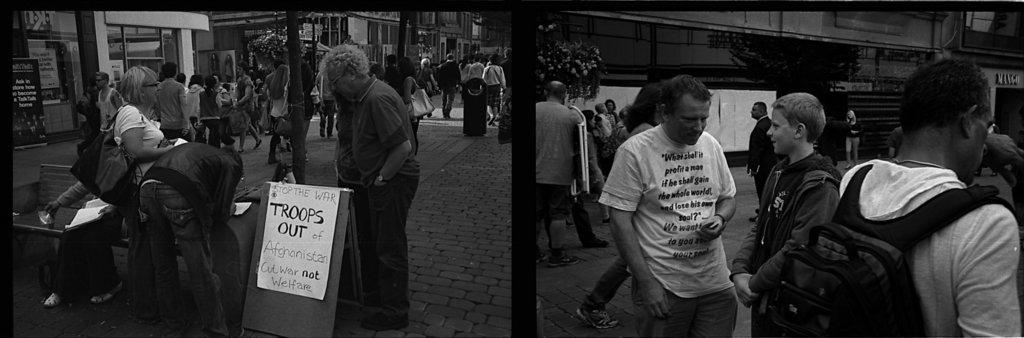What is the color scheme of the images? The images are black and white. What can be seen on the road in the images? There are people walking on the road. What structures are located beside the road? There are buildings beside the road. What objects are visible in the images with text or information? There are boards visible in the image. What type of vegetation is present in the images? There are plants in the image. What type of silk is being used to make the lock on the door in the image? There is no lock or silk present in the image; it features people walking on the road, buildings, boards, and plants. 